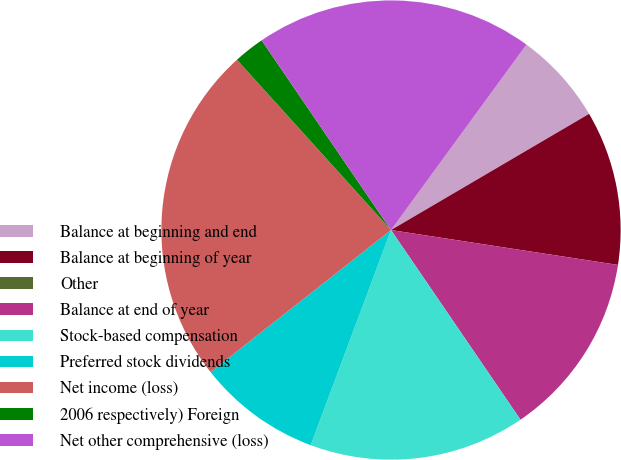<chart> <loc_0><loc_0><loc_500><loc_500><pie_chart><fcel>Balance at beginning and end<fcel>Balance at beginning of year<fcel>Other<fcel>Balance at end of year<fcel>Stock-based compensation<fcel>Preferred stock dividends<fcel>Net income (loss)<fcel>2006 respectively) Foreign<fcel>Net other comprehensive (loss)<nl><fcel>6.52%<fcel>10.87%<fcel>0.0%<fcel>13.04%<fcel>15.22%<fcel>8.7%<fcel>23.91%<fcel>2.18%<fcel>19.56%<nl></chart> 